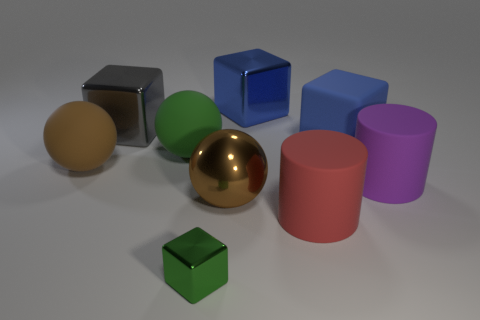Subtract all brown rubber spheres. How many spheres are left? 2 Subtract all purple spheres. How many blue blocks are left? 2 Add 1 tiny cyan spheres. How many objects exist? 10 Subtract 1 cubes. How many cubes are left? 3 Subtract all gray blocks. How many blocks are left? 3 Subtract all yellow blocks. Subtract all gray cylinders. How many blocks are left? 4 Subtract 2 brown spheres. How many objects are left? 7 Subtract all balls. How many objects are left? 6 Subtract all green matte balls. Subtract all purple things. How many objects are left? 7 Add 7 shiny spheres. How many shiny spheres are left? 8 